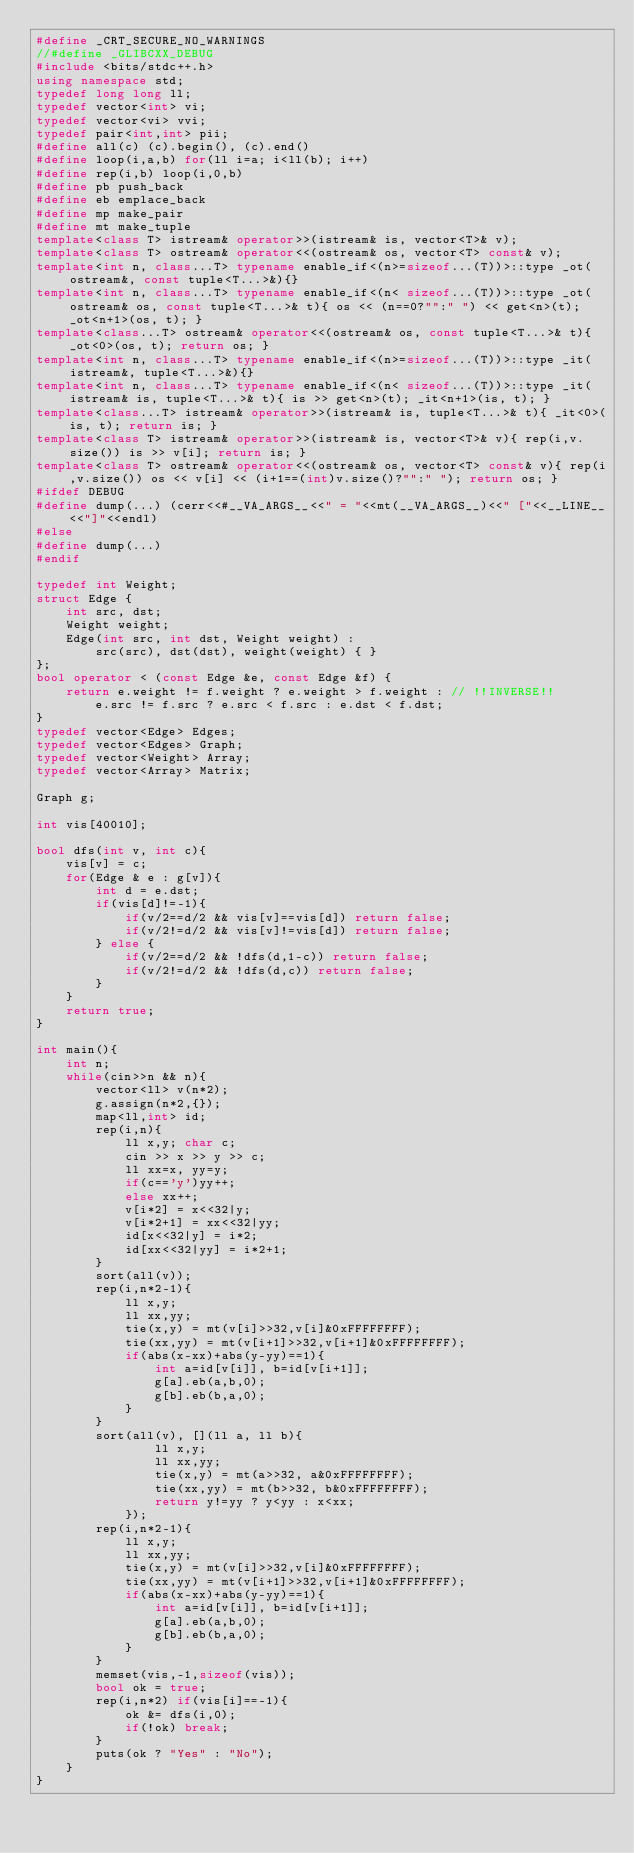Convert code to text. <code><loc_0><loc_0><loc_500><loc_500><_C++_>#define _CRT_SECURE_NO_WARNINGS
//#define _GLIBCXX_DEBUG
#include <bits/stdc++.h>
using namespace std;
typedef long long ll;
typedef vector<int> vi;
typedef vector<vi> vvi;
typedef pair<int,int> pii;
#define all(c) (c).begin(), (c).end()
#define loop(i,a,b) for(ll i=a; i<ll(b); i++)
#define rep(i,b) loop(i,0,b)
#define pb push_back
#define eb emplace_back
#define mp make_pair
#define mt make_tuple
template<class T> istream& operator>>(istream& is, vector<T>& v);
template<class T> ostream& operator<<(ostream& os, vector<T> const& v);
template<int n, class...T> typename enable_if<(n>=sizeof...(T))>::type _ot(ostream&, const tuple<T...>&){}
template<int n, class...T> typename enable_if<(n< sizeof...(T))>::type _ot(ostream& os, const tuple<T...>& t){ os << (n==0?"":" ") << get<n>(t); _ot<n+1>(os, t); }
template<class...T> ostream& operator<<(ostream& os, const tuple<T...>& t){ _ot<0>(os, t); return os; }
template<int n, class...T> typename enable_if<(n>=sizeof...(T))>::type _it(istream&, tuple<T...>&){}
template<int n, class...T> typename enable_if<(n< sizeof...(T))>::type _it(istream& is, tuple<T...>& t){ is >> get<n>(t); _it<n+1>(is, t); }
template<class...T> istream& operator>>(istream& is, tuple<T...>& t){ _it<0>(is, t); return is; }
template<class T> istream& operator>>(istream& is, vector<T>& v){ rep(i,v.size()) is >> v[i]; return is; }
template<class T> ostream& operator<<(ostream& os, vector<T> const& v){ rep(i,v.size()) os << v[i] << (i+1==(int)v.size()?"":" "); return os; }
#ifdef DEBUG
#define dump(...) (cerr<<#__VA_ARGS__<<" = "<<mt(__VA_ARGS__)<<" ["<<__LINE__<<"]"<<endl)
#else
#define dump(...)
#endif

typedef int Weight;
struct Edge {
    int src, dst;
    Weight weight;
    Edge(int src, int dst, Weight weight) :
        src(src), dst(dst), weight(weight) { }
};
bool operator < (const Edge &e, const Edge &f) {
    return e.weight != f.weight ? e.weight > f.weight : // !!INVERSE!!
        e.src != f.src ? e.src < f.src : e.dst < f.dst;
}
typedef vector<Edge> Edges;
typedef vector<Edges> Graph;
typedef vector<Weight> Array;
typedef vector<Array> Matrix;

Graph g;

int vis[40010];

bool dfs(int v, int c){
    vis[v] = c;
    for(Edge & e : g[v]){
        int d = e.dst;
        if(vis[d]!=-1){
            if(v/2==d/2 && vis[v]==vis[d]) return false;
            if(v/2!=d/2 && vis[v]!=vis[d]) return false;
        } else {
            if(v/2==d/2 && !dfs(d,1-c)) return false;
            if(v/2!=d/2 && !dfs(d,c)) return false;
        }
    }
    return true;
}

int main(){
    int n;
    while(cin>>n && n){
        vector<ll> v(n*2);
        g.assign(n*2,{});
        map<ll,int> id;
        rep(i,n){
            ll x,y; char c;
            cin >> x >> y >> c;
            ll xx=x, yy=y;
            if(c=='y')yy++;
            else xx++;
            v[i*2] = x<<32|y;
            v[i*2+1] = xx<<32|yy;
            id[x<<32|y] = i*2;
            id[xx<<32|yy] = i*2+1;
        }
        sort(all(v));
        rep(i,n*2-1){
            ll x,y;
            ll xx,yy;
            tie(x,y) = mt(v[i]>>32,v[i]&0xFFFFFFFF);
            tie(xx,yy) = mt(v[i+1]>>32,v[i+1]&0xFFFFFFFF);
            if(abs(x-xx)+abs(y-yy)==1){
                int a=id[v[i]], b=id[v[i+1]];
                g[a].eb(a,b,0);
                g[b].eb(b,a,0);
            }
        }
        sort(all(v), [](ll a, ll b){
                ll x,y;
                ll xx,yy;
                tie(x,y) = mt(a>>32, a&0xFFFFFFFF);
                tie(xx,yy) = mt(b>>32, b&0xFFFFFFFF);
                return y!=yy ? y<yy : x<xx;
            });
        rep(i,n*2-1){
            ll x,y;
            ll xx,yy;
            tie(x,y) = mt(v[i]>>32,v[i]&0xFFFFFFFF);
            tie(xx,yy) = mt(v[i+1]>>32,v[i+1]&0xFFFFFFFF);
            if(abs(x-xx)+abs(y-yy)==1){
                int a=id[v[i]], b=id[v[i+1]];
                g[a].eb(a,b,0);
                g[b].eb(b,a,0);
            }
        }
        memset(vis,-1,sizeof(vis));
        bool ok = true;
        rep(i,n*2) if(vis[i]==-1){
            ok &= dfs(i,0);
            if(!ok) break;
        }
        puts(ok ? "Yes" : "No");
    }
}</code> 